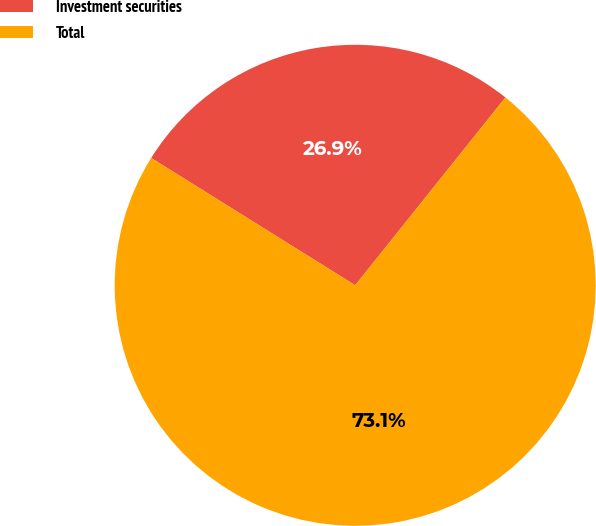<chart> <loc_0><loc_0><loc_500><loc_500><pie_chart><fcel>Investment securities<fcel>Total<nl><fcel>26.86%<fcel>73.14%<nl></chart> 